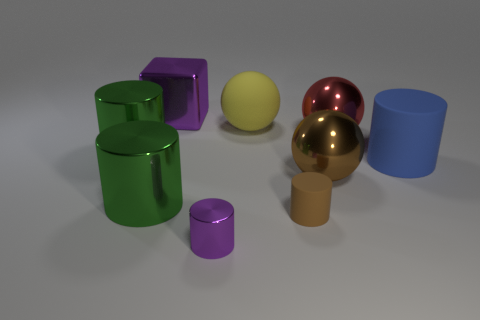Subtract all brown cylinders. How many cylinders are left? 4 Subtract all purple cylinders. How many cylinders are left? 4 Subtract 1 balls. How many balls are left? 2 Add 1 purple cylinders. How many objects exist? 10 Subtract all balls. How many objects are left? 6 Subtract all yellow spheres. Subtract all green cylinders. How many spheres are left? 2 Subtract all brown balls. How many blue blocks are left? 0 Subtract all blue shiny spheres. Subtract all purple metal blocks. How many objects are left? 8 Add 5 big blue cylinders. How many big blue cylinders are left? 6 Add 3 tiny objects. How many tiny objects exist? 5 